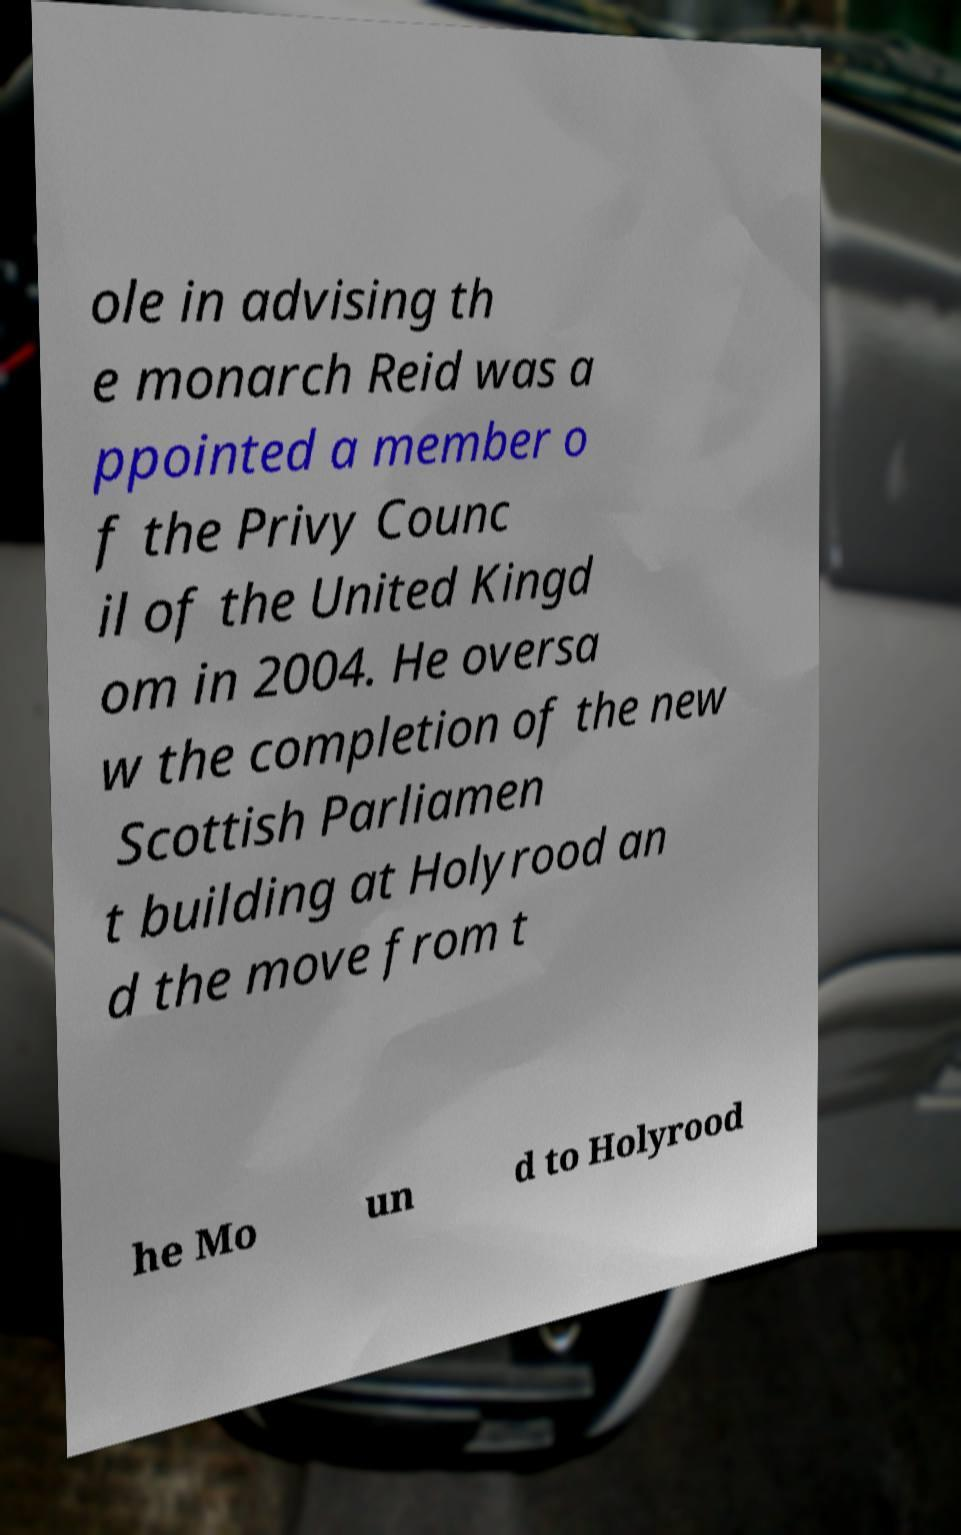What messages or text are displayed in this image? I need them in a readable, typed format. ole in advising th e monarch Reid was a ppointed a member o f the Privy Counc il of the United Kingd om in 2004. He oversa w the completion of the new Scottish Parliamen t building at Holyrood an d the move from t he Mo un d to Holyrood 